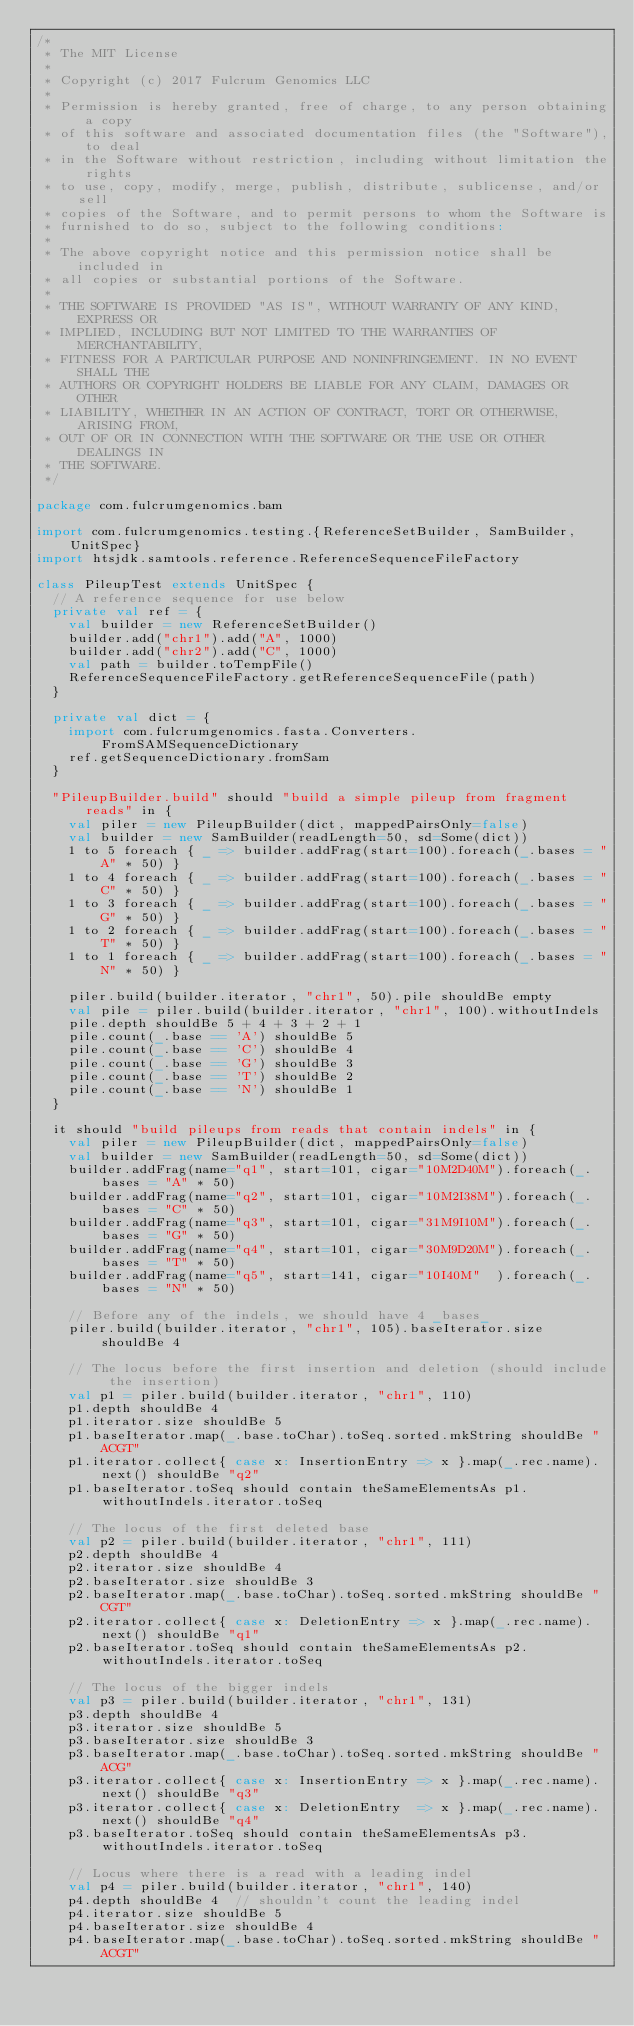Convert code to text. <code><loc_0><loc_0><loc_500><loc_500><_Scala_>/*
 * The MIT License
 *
 * Copyright (c) 2017 Fulcrum Genomics LLC
 *
 * Permission is hereby granted, free of charge, to any person obtaining a copy
 * of this software and associated documentation files (the "Software"), to deal
 * in the Software without restriction, including without limitation the rights
 * to use, copy, modify, merge, publish, distribute, sublicense, and/or sell
 * copies of the Software, and to permit persons to whom the Software is
 * furnished to do so, subject to the following conditions:
 *
 * The above copyright notice and this permission notice shall be included in
 * all copies or substantial portions of the Software.
 *
 * THE SOFTWARE IS PROVIDED "AS IS", WITHOUT WARRANTY OF ANY KIND, EXPRESS OR
 * IMPLIED, INCLUDING BUT NOT LIMITED TO THE WARRANTIES OF MERCHANTABILITY,
 * FITNESS FOR A PARTICULAR PURPOSE AND NONINFRINGEMENT. IN NO EVENT SHALL THE
 * AUTHORS OR COPYRIGHT HOLDERS BE LIABLE FOR ANY CLAIM, DAMAGES OR OTHER
 * LIABILITY, WHETHER IN AN ACTION OF CONTRACT, TORT OR OTHERWISE, ARISING FROM,
 * OUT OF OR IN CONNECTION WITH THE SOFTWARE OR THE USE OR OTHER DEALINGS IN
 * THE SOFTWARE.
 */

package com.fulcrumgenomics.bam

import com.fulcrumgenomics.testing.{ReferenceSetBuilder, SamBuilder, UnitSpec}
import htsjdk.samtools.reference.ReferenceSequenceFileFactory

class PileupTest extends UnitSpec {
  // A reference sequence for use below
  private val ref = {
    val builder = new ReferenceSetBuilder()
    builder.add("chr1").add("A", 1000)
    builder.add("chr2").add("C", 1000)
    val path = builder.toTempFile()
    ReferenceSequenceFileFactory.getReferenceSequenceFile(path)
  }

  private val dict = {
    import com.fulcrumgenomics.fasta.Converters.FromSAMSequenceDictionary
    ref.getSequenceDictionary.fromSam
  }

  "PileupBuilder.build" should "build a simple pileup from fragment reads" in {
    val piler = new PileupBuilder(dict, mappedPairsOnly=false)
    val builder = new SamBuilder(readLength=50, sd=Some(dict))
    1 to 5 foreach { _ => builder.addFrag(start=100).foreach(_.bases = "A" * 50) }
    1 to 4 foreach { _ => builder.addFrag(start=100).foreach(_.bases = "C" * 50) }
    1 to 3 foreach { _ => builder.addFrag(start=100).foreach(_.bases = "G" * 50) }
    1 to 2 foreach { _ => builder.addFrag(start=100).foreach(_.bases = "T" * 50) }
    1 to 1 foreach { _ => builder.addFrag(start=100).foreach(_.bases = "N" * 50) }

    piler.build(builder.iterator, "chr1", 50).pile shouldBe empty
    val pile = piler.build(builder.iterator, "chr1", 100).withoutIndels
    pile.depth shouldBe 5 + 4 + 3 + 2 + 1
    pile.count(_.base == 'A') shouldBe 5
    pile.count(_.base == 'C') shouldBe 4
    pile.count(_.base == 'G') shouldBe 3
    pile.count(_.base == 'T') shouldBe 2
    pile.count(_.base == 'N') shouldBe 1
  }

  it should "build pileups from reads that contain indels" in {
    val piler = new PileupBuilder(dict, mappedPairsOnly=false)
    val builder = new SamBuilder(readLength=50, sd=Some(dict))
    builder.addFrag(name="q1", start=101, cigar="10M2D40M").foreach(_.bases = "A" * 50)
    builder.addFrag(name="q2", start=101, cigar="10M2I38M").foreach(_.bases = "C" * 50)
    builder.addFrag(name="q3", start=101, cigar="31M9I10M").foreach(_.bases = "G" * 50)
    builder.addFrag(name="q4", start=101, cigar="30M9D20M").foreach(_.bases = "T" * 50)
    builder.addFrag(name="q5", start=141, cigar="10I40M"  ).foreach(_.bases = "N" * 50)

    // Before any of the indels, we should have 4 _bases_
    piler.build(builder.iterator, "chr1", 105).baseIterator.size shouldBe 4

    // The locus before the first insertion and deletion (should include the insertion)
    val p1 = piler.build(builder.iterator, "chr1", 110)
    p1.depth shouldBe 4
    p1.iterator.size shouldBe 5
    p1.baseIterator.map(_.base.toChar).toSeq.sorted.mkString shouldBe "ACGT"
    p1.iterator.collect{ case x: InsertionEntry => x }.map(_.rec.name).next() shouldBe "q2"
    p1.baseIterator.toSeq should contain theSameElementsAs p1.withoutIndels.iterator.toSeq

    // The locus of the first deleted base
    val p2 = piler.build(builder.iterator, "chr1", 111)
    p2.depth shouldBe 4
    p2.iterator.size shouldBe 4
    p2.baseIterator.size shouldBe 3
    p2.baseIterator.map(_.base.toChar).toSeq.sorted.mkString shouldBe "CGT"
    p2.iterator.collect{ case x: DeletionEntry => x }.map(_.rec.name).next() shouldBe "q1"
    p2.baseIterator.toSeq should contain theSameElementsAs p2.withoutIndels.iterator.toSeq

    // The locus of the bigger indels
    val p3 = piler.build(builder.iterator, "chr1", 131)
    p3.depth shouldBe 4
    p3.iterator.size shouldBe 5
    p3.baseIterator.size shouldBe 3
    p3.baseIterator.map(_.base.toChar).toSeq.sorted.mkString shouldBe "ACG"
    p3.iterator.collect{ case x: InsertionEntry => x }.map(_.rec.name).next() shouldBe "q3"
    p3.iterator.collect{ case x: DeletionEntry  => x }.map(_.rec.name).next() shouldBe "q4"
    p3.baseIterator.toSeq should contain theSameElementsAs p3.withoutIndels.iterator.toSeq

    // Locus where there is a read with a leading indel
    val p4 = piler.build(builder.iterator, "chr1", 140)
    p4.depth shouldBe 4  // shouldn't count the leading indel
    p4.iterator.size shouldBe 5
    p4.baseIterator.size shouldBe 4
    p4.baseIterator.map(_.base.toChar).toSeq.sorted.mkString shouldBe "ACGT"</code> 